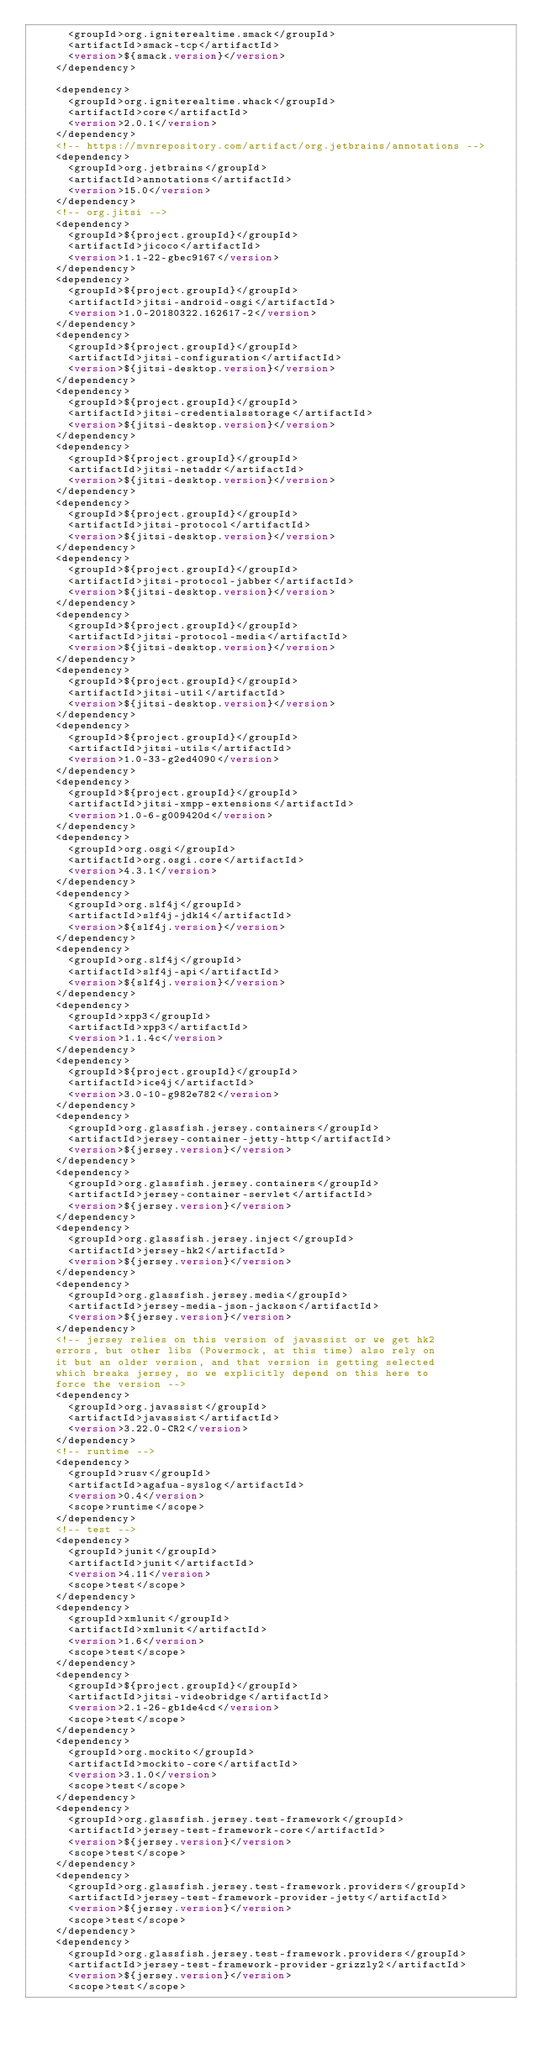<code> <loc_0><loc_0><loc_500><loc_500><_XML_>      <groupId>org.igniterealtime.smack</groupId>
      <artifactId>smack-tcp</artifactId>
      <version>${smack.version}</version>
    </dependency>

    <dependency>
      <groupId>org.igniterealtime.whack</groupId>
      <artifactId>core</artifactId>
      <version>2.0.1</version>
    </dependency>
    <!-- https://mvnrepository.com/artifact/org.jetbrains/annotations -->
    <dependency>
      <groupId>org.jetbrains</groupId>
      <artifactId>annotations</artifactId>
      <version>15.0</version>
    </dependency>
    <!-- org.jitsi -->
    <dependency>
      <groupId>${project.groupId}</groupId>
      <artifactId>jicoco</artifactId>
      <version>1.1-22-gbec9167</version>
    </dependency>
    <dependency>
      <groupId>${project.groupId}</groupId>
      <artifactId>jitsi-android-osgi</artifactId>
      <version>1.0-20180322.162617-2</version>
    </dependency>
    <dependency>
      <groupId>${project.groupId}</groupId>
      <artifactId>jitsi-configuration</artifactId>
      <version>${jitsi-desktop.version}</version>
    </dependency>
    <dependency>
      <groupId>${project.groupId}</groupId>
      <artifactId>jitsi-credentialsstorage</artifactId>
      <version>${jitsi-desktop.version}</version>
    </dependency>
    <dependency>
      <groupId>${project.groupId}</groupId>
      <artifactId>jitsi-netaddr</artifactId>
      <version>${jitsi-desktop.version}</version>
    </dependency>
    <dependency>
      <groupId>${project.groupId}</groupId>
      <artifactId>jitsi-protocol</artifactId>
      <version>${jitsi-desktop.version}</version>
    </dependency>
    <dependency>
      <groupId>${project.groupId}</groupId>
      <artifactId>jitsi-protocol-jabber</artifactId>
      <version>${jitsi-desktop.version}</version>
    </dependency>
    <dependency>
      <groupId>${project.groupId}</groupId>
      <artifactId>jitsi-protocol-media</artifactId>
      <version>${jitsi-desktop.version}</version>
    </dependency>
    <dependency>
      <groupId>${project.groupId}</groupId>
      <artifactId>jitsi-util</artifactId>
      <version>${jitsi-desktop.version}</version>
    </dependency>
    <dependency>
      <groupId>${project.groupId}</groupId>
      <artifactId>jitsi-utils</artifactId>
      <version>1.0-33-g2ed4090</version>
    </dependency>
    <dependency>
      <groupId>${project.groupId}</groupId>
      <artifactId>jitsi-xmpp-extensions</artifactId>
      <version>1.0-6-g009420d</version>
    </dependency>
    <dependency>
      <groupId>org.osgi</groupId>
      <artifactId>org.osgi.core</artifactId>
      <version>4.3.1</version>
    </dependency>
    <dependency>
      <groupId>org.slf4j</groupId>
      <artifactId>slf4j-jdk14</artifactId>
      <version>${slf4j.version}</version>
    </dependency>
    <dependency>
      <groupId>org.slf4j</groupId>
      <artifactId>slf4j-api</artifactId>
      <version>${slf4j.version}</version>
    </dependency>
    <dependency>
      <groupId>xpp3</groupId>
      <artifactId>xpp3</artifactId>
      <version>1.1.4c</version>
    </dependency>
    <dependency>
      <groupId>${project.groupId}</groupId>
      <artifactId>ice4j</artifactId>
      <version>3.0-10-g982e782</version>
    </dependency>
    <dependency>
      <groupId>org.glassfish.jersey.containers</groupId>
      <artifactId>jersey-container-jetty-http</artifactId>
      <version>${jersey.version}</version>
    </dependency>
    <dependency>
      <groupId>org.glassfish.jersey.containers</groupId>
      <artifactId>jersey-container-servlet</artifactId>
      <version>${jersey.version}</version>
    </dependency>
    <dependency>
      <groupId>org.glassfish.jersey.inject</groupId>
      <artifactId>jersey-hk2</artifactId>
      <version>${jersey.version}</version>
    </dependency>
    <dependency>
      <groupId>org.glassfish.jersey.media</groupId>
      <artifactId>jersey-media-json-jackson</artifactId>
      <version>${jersey.version}</version>
    </dependency>
    <!-- jersey relies on this version of javassist or we get hk2
    errors, but other libs (Powermock, at this time) also rely on
    it but an older version, and that version is getting selected
    which breaks jersey, so we explicitly depend on this here to
    force the version -->
    <dependency>
      <groupId>org.javassist</groupId>
      <artifactId>javassist</artifactId>
      <version>3.22.0-CR2</version>
    </dependency>
    <!-- runtime -->
    <dependency>
      <groupId>rusv</groupId>
      <artifactId>agafua-syslog</artifactId>
      <version>0.4</version>
      <scope>runtime</scope>
    </dependency>
    <!-- test -->
    <dependency>
      <groupId>junit</groupId>
      <artifactId>junit</artifactId>
      <version>4.11</version>
      <scope>test</scope>
    </dependency>
    <dependency>
      <groupId>xmlunit</groupId>
      <artifactId>xmlunit</artifactId>
      <version>1.6</version>
      <scope>test</scope>
    </dependency>
    <dependency>
      <groupId>${project.groupId}</groupId>
      <artifactId>jitsi-videobridge</artifactId>
      <version>2.1-26-gb1de4cd</version>
      <scope>test</scope>
    </dependency>
    <dependency>
      <groupId>org.mockito</groupId>
      <artifactId>mockito-core</artifactId>
      <version>3.1.0</version>
      <scope>test</scope>
    </dependency>
    <dependency>
      <groupId>org.glassfish.jersey.test-framework</groupId>
      <artifactId>jersey-test-framework-core</artifactId>
      <version>${jersey.version}</version>
      <scope>test</scope>
    </dependency>
    <dependency>
      <groupId>org.glassfish.jersey.test-framework.providers</groupId>
      <artifactId>jersey-test-framework-provider-jetty</artifactId>
      <version>${jersey.version}</version>
      <scope>test</scope>
    </dependency>
    <dependency>
      <groupId>org.glassfish.jersey.test-framework.providers</groupId>
      <artifactId>jersey-test-framework-provider-grizzly2</artifactId>
      <version>${jersey.version}</version>
      <scope>test</scope></code> 